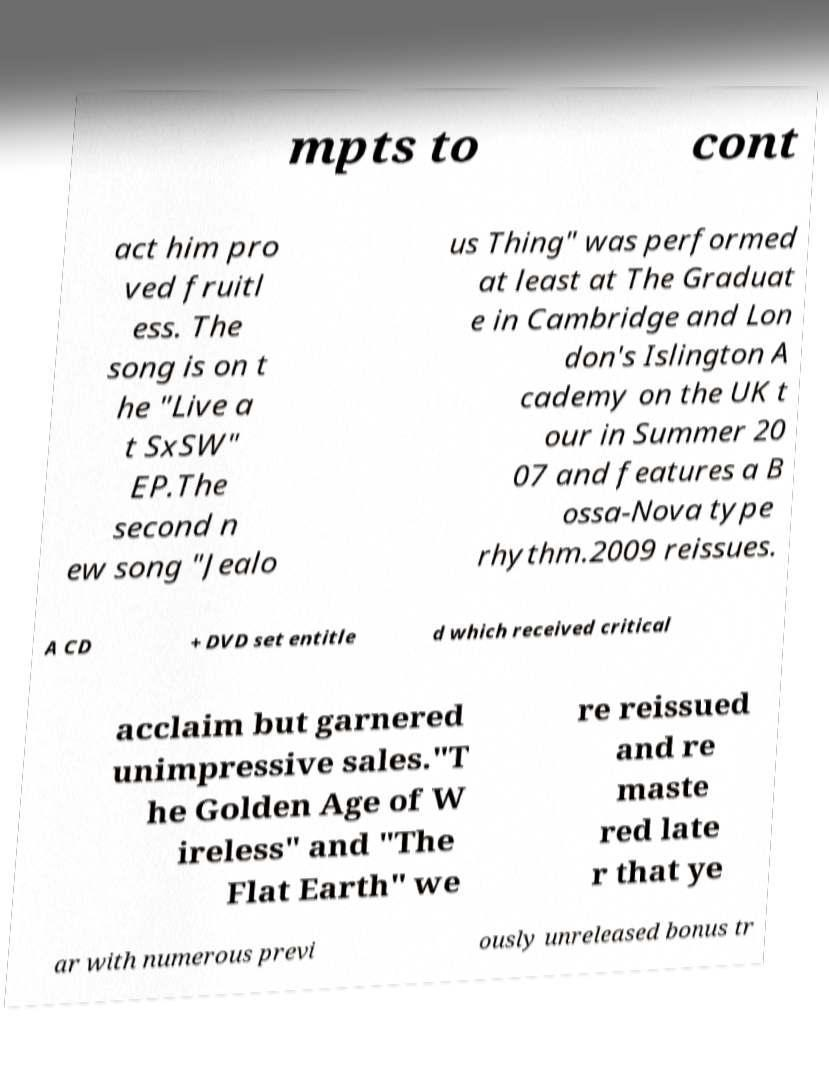There's text embedded in this image that I need extracted. Can you transcribe it verbatim? mpts to cont act him pro ved fruitl ess. The song is on t he "Live a t SxSW" EP.The second n ew song "Jealo us Thing" was performed at least at The Graduat e in Cambridge and Lon don's Islington A cademy on the UK t our in Summer 20 07 and features a B ossa-Nova type rhythm.2009 reissues. A CD + DVD set entitle d which received critical acclaim but garnered unimpressive sales."T he Golden Age of W ireless" and "The Flat Earth" we re reissued and re maste red late r that ye ar with numerous previ ously unreleased bonus tr 